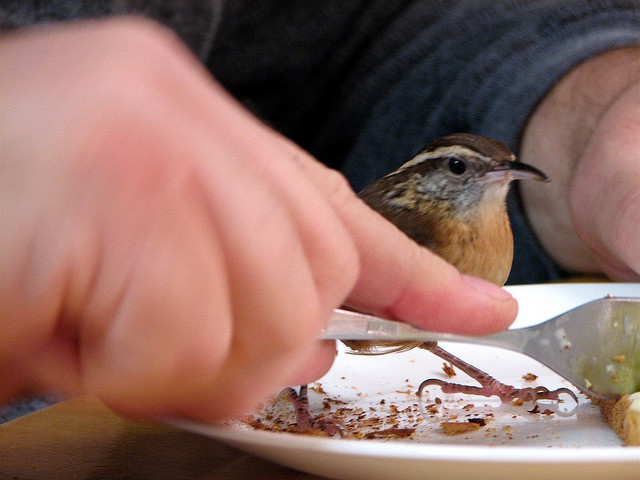Describe the objects in this image and their specific colors. I can see people in black, lightpink, salmon, and brown tones, bird in black, gray, and maroon tones, dining table in black, maroon, and brown tones, spoon in black, darkgray, and gray tones, and fork in black, darkgray, gray, and pink tones in this image. 